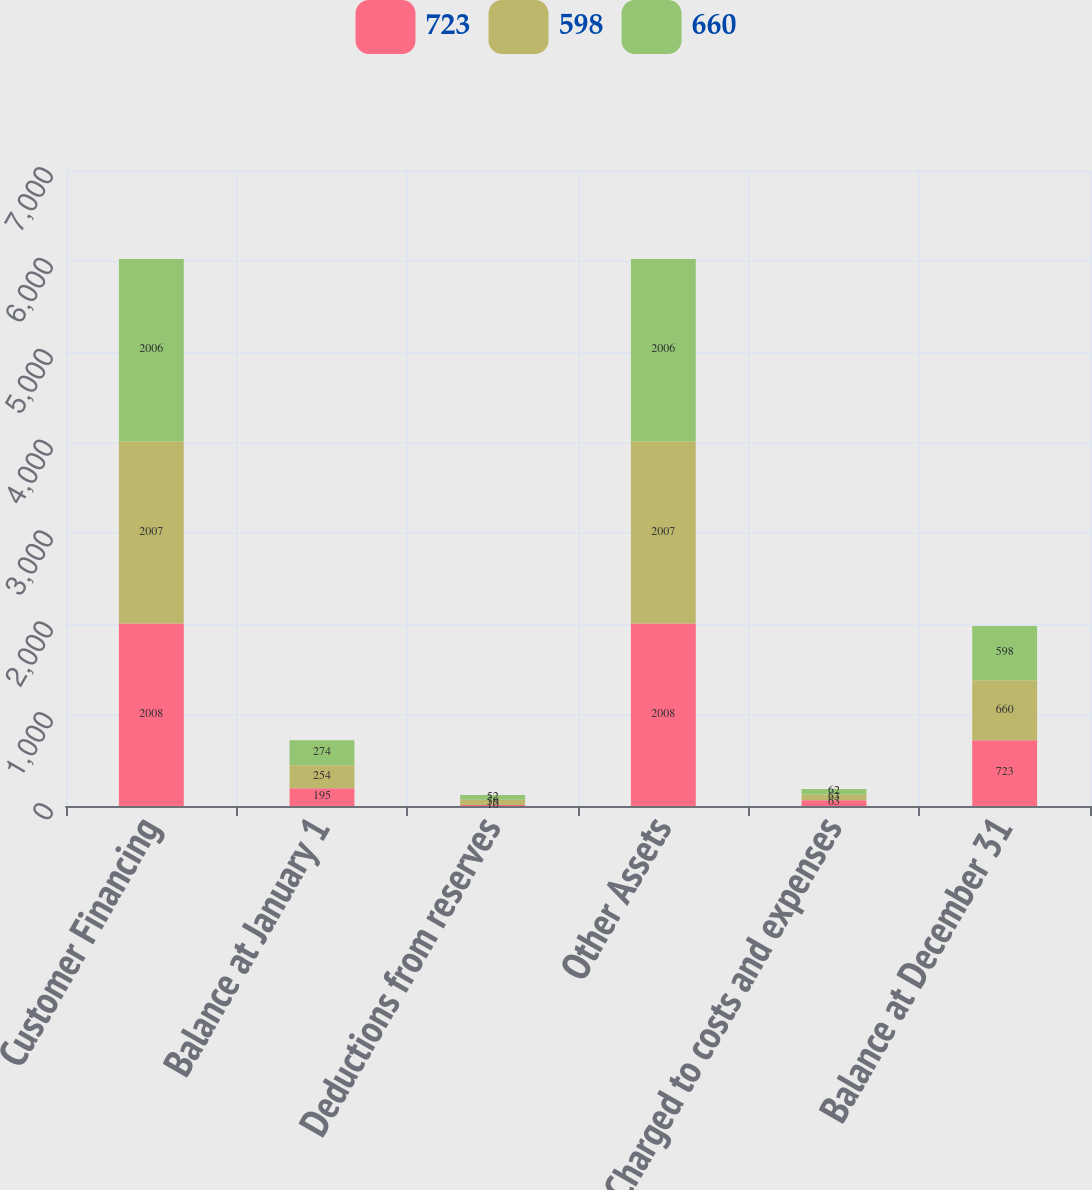Convert chart to OTSL. <chart><loc_0><loc_0><loc_500><loc_500><stacked_bar_chart><ecel><fcel>Customer Financing<fcel>Balance at January 1<fcel>Deductions from reserves<fcel>Other Assets<fcel>Charged to costs and expenses<fcel>Balance at December 31<nl><fcel>723<fcel>2008<fcel>195<fcel>10<fcel>2008<fcel>63<fcel>723<nl><fcel>598<fcel>2007<fcel>254<fcel>59<fcel>2007<fcel>63<fcel>660<nl><fcel>660<fcel>2006<fcel>274<fcel>52<fcel>2006<fcel>62<fcel>598<nl></chart> 